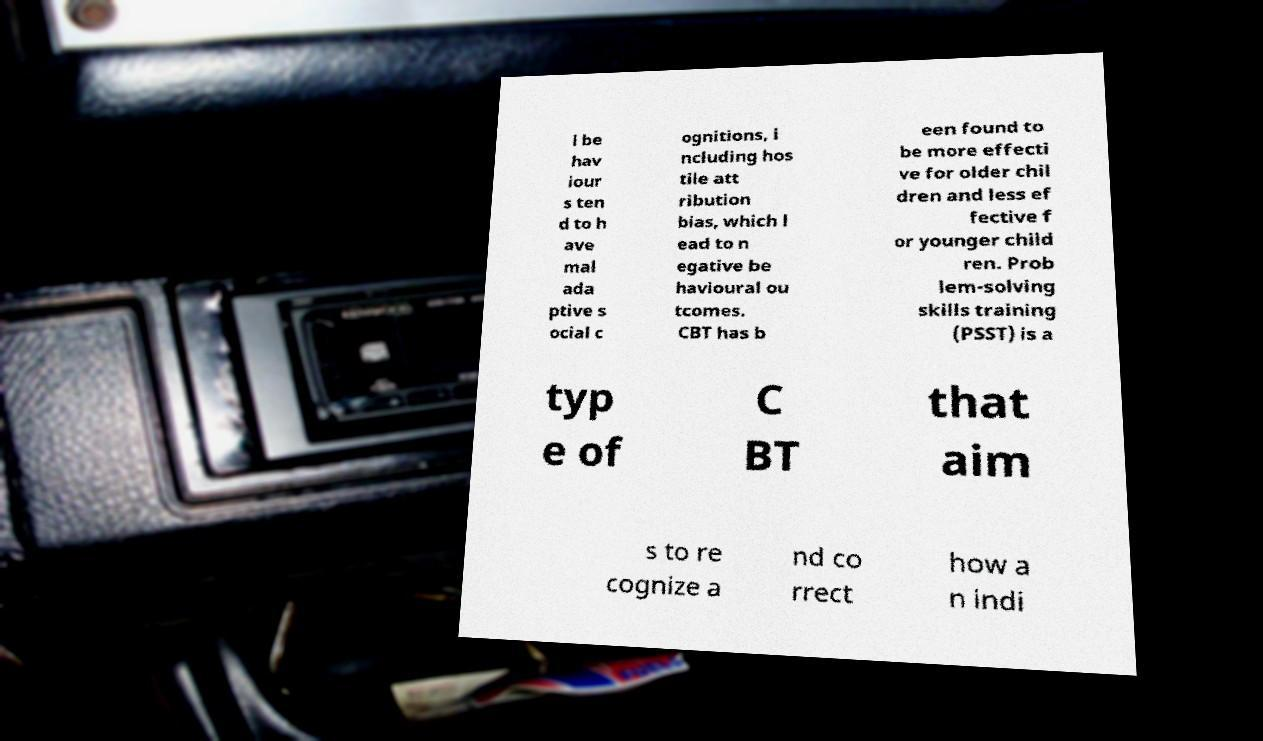For documentation purposes, I need the text within this image transcribed. Could you provide that? l be hav iour s ten d to h ave mal ada ptive s ocial c ognitions, i ncluding hos tile att ribution bias, which l ead to n egative be havioural ou tcomes. CBT has b een found to be more effecti ve for older chil dren and less ef fective f or younger child ren. Prob lem-solving skills training (PSST) is a typ e of C BT that aim s to re cognize a nd co rrect how a n indi 